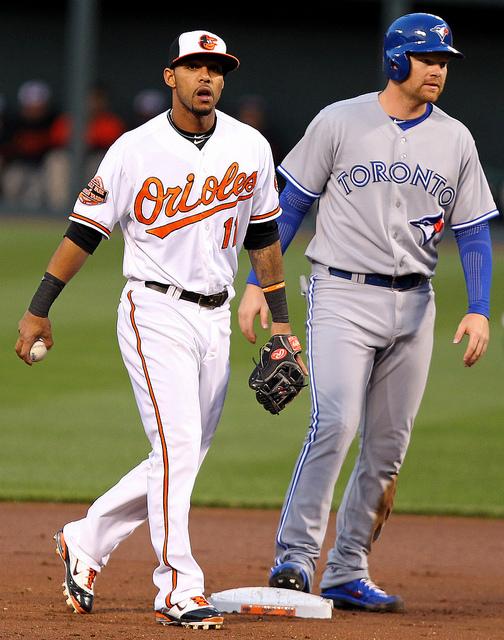What baseball team do these men play for?
Be succinct. Orioles and toronto. Are both teams playing Canadian?
Give a very brief answer. No. How many players are wearing a helmet?
Be succinct. 1. Are they both from the same team?
Write a very short answer. No. Has this baseball team ever won a world series?
Be succinct. Yes. 